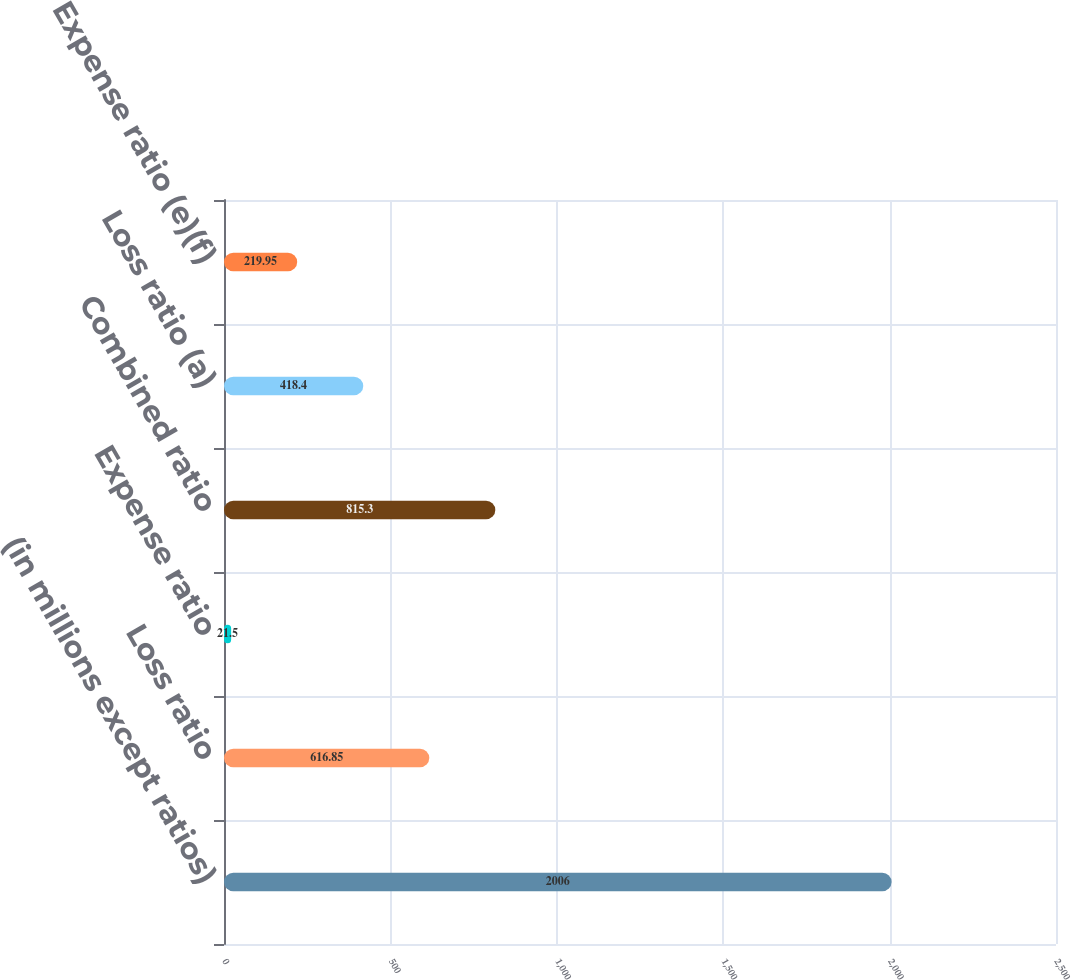Convert chart. <chart><loc_0><loc_0><loc_500><loc_500><bar_chart><fcel>(in millions except ratios)<fcel>Loss ratio<fcel>Expense ratio<fcel>Combined ratio<fcel>Loss ratio (a)<fcel>Expense ratio (e)(f)<nl><fcel>2006<fcel>616.85<fcel>21.5<fcel>815.3<fcel>418.4<fcel>219.95<nl></chart> 